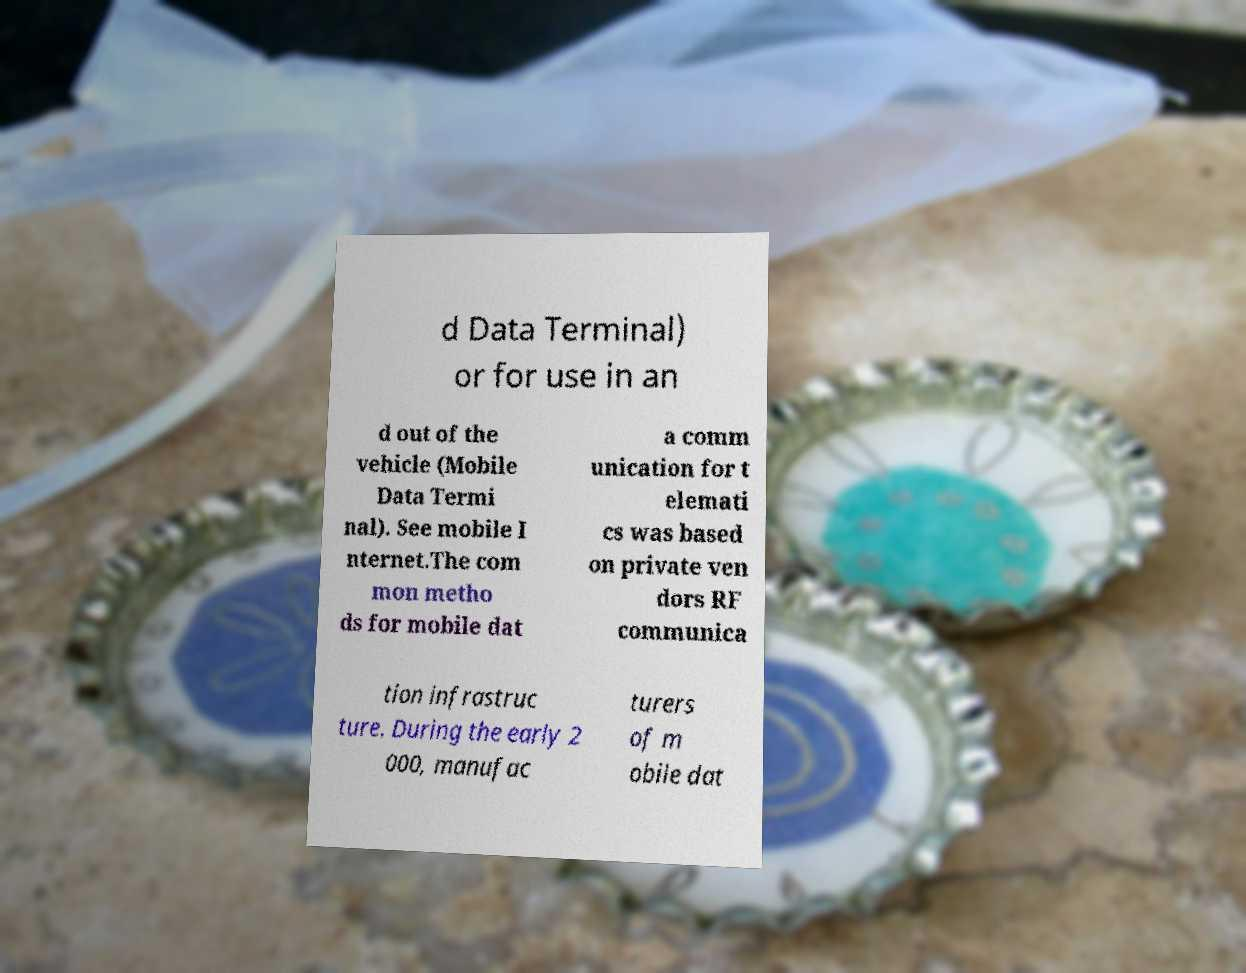There's text embedded in this image that I need extracted. Can you transcribe it verbatim? d Data Terminal) or for use in an d out of the vehicle (Mobile Data Termi nal). See mobile I nternet.The com mon metho ds for mobile dat a comm unication for t elemati cs was based on private ven dors RF communica tion infrastruc ture. During the early 2 000, manufac turers of m obile dat 